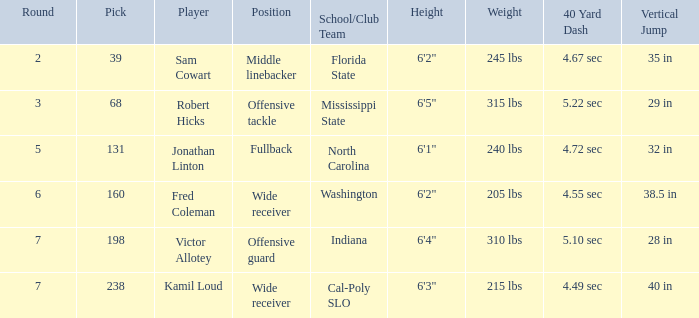Which Round has a School/Club Team of cal-poly slo, and a Pick smaller than 238? None. 